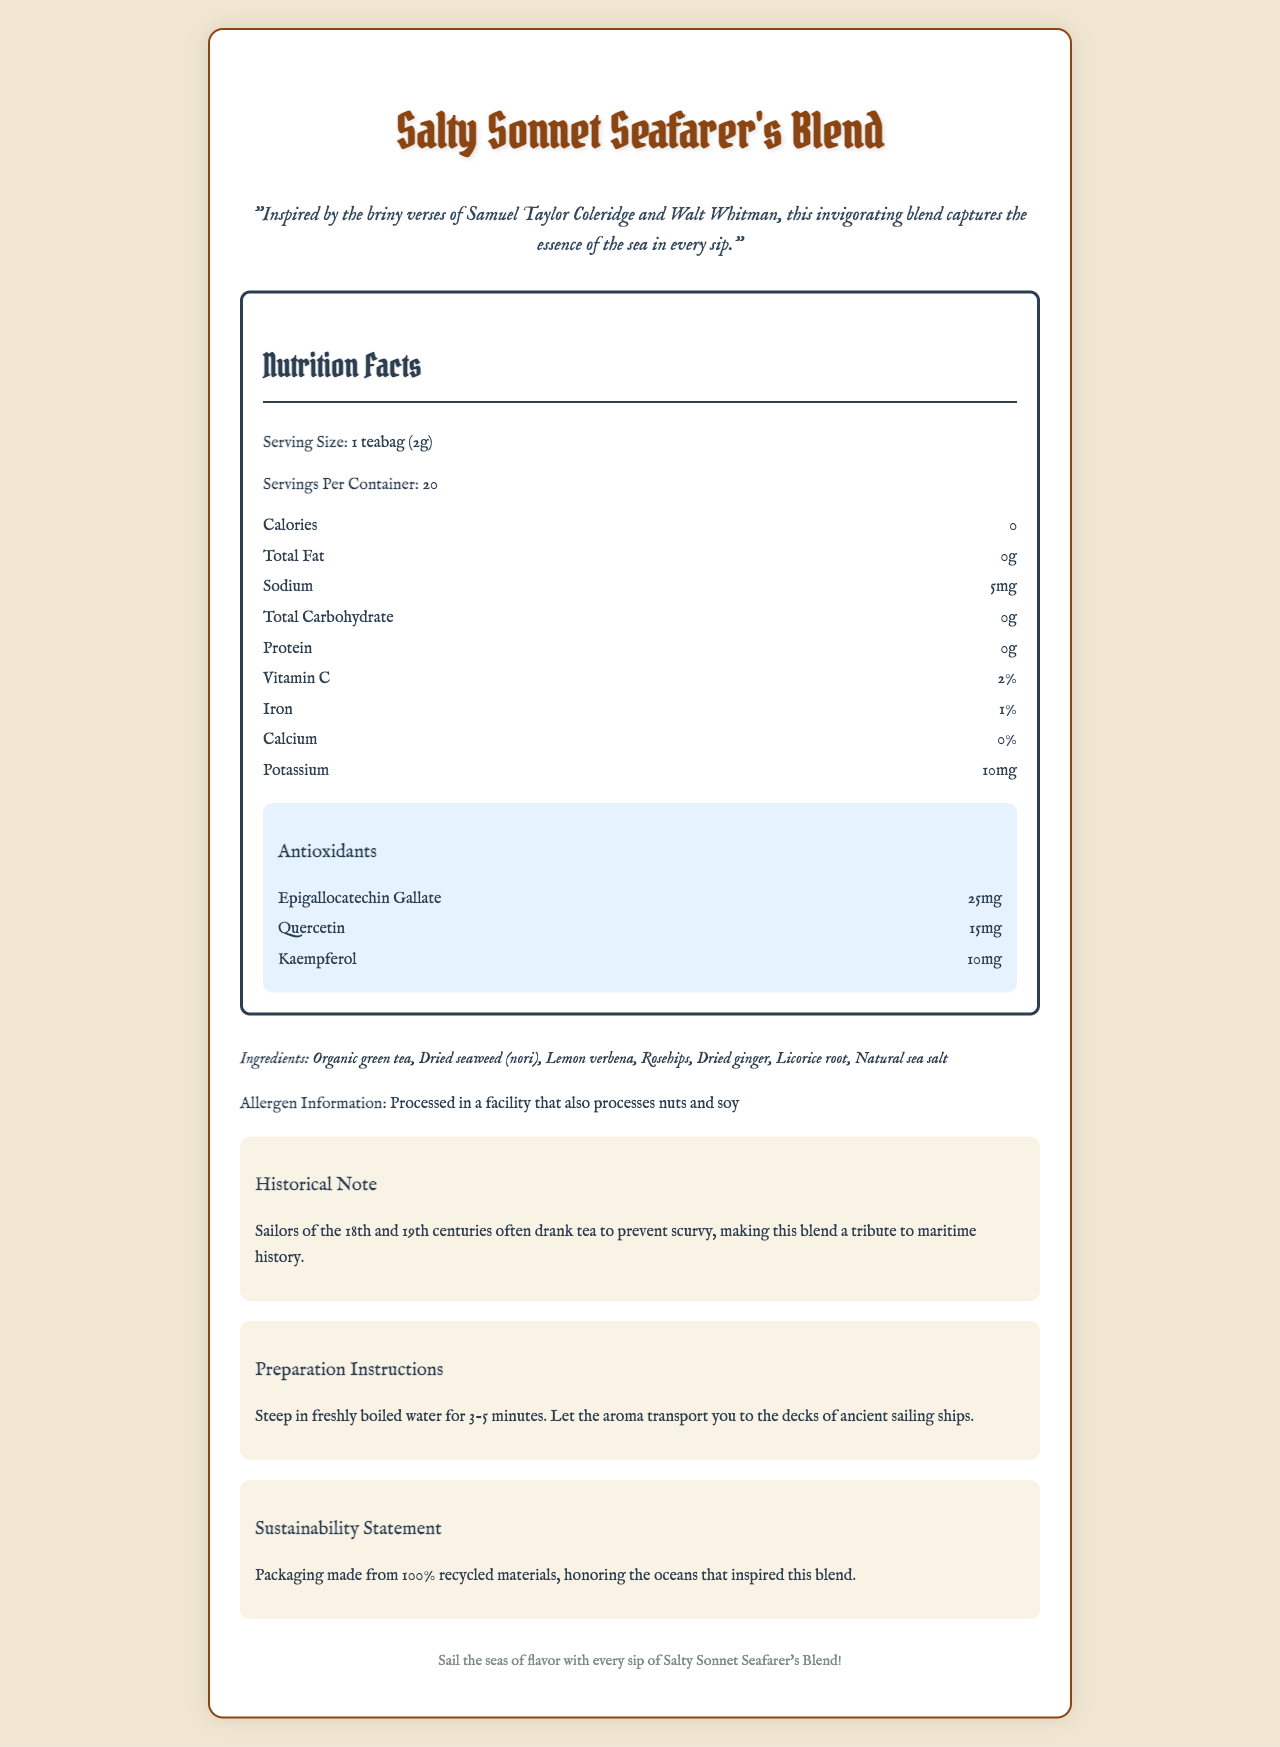what is the serving size for Salty Sonnet Seafarer's Blend? The serving size is directly mentioned in the Nutrition Facts section.
Answer: 1 teabag (2g) how many servings are there per container? The document states that there are 20 servings per container.
Answer: 20 how much sodium does one serving contain? The sodium content per serving is listed under the Nutrition Facts as 5mg.
Answer: 5mg what ingredients are used in the Salty Sonnet Seafarer's Blend? The ingredients are listed in the Ingredients section.
Answer: Organic green tea, Dried seaweed (nori), Lemon verbena, Rosehips, Dried ginger, Licorice root, Natural sea salt what is the poetic inspiration behind Salty Sonnet Seafarer's Blend? The poetic description section mentions that the blend is inspired by Samuel Taylor Coleridge and Walt Whitman.
Answer: The briny verses of Samuel Taylor Coleridge and Walt Whitman which historical practice does this tea blend pay homage to? A. Drinking water on ships B. Sailors drinking coffee C. Sailors drinking tea to prevent scurvy The historical note states that sailors of the 18th and 19th centuries drank tea to prevent scurvy.
Answer: C which antioxidant has the highest content in this tea blend? A. Epigallocatechin Gallate B. Quercetin C. Kaempferol The document lists Epigallocatechin Gallate with 25mg, which is higher than Quercetin (15mg) and Kaempferol (10mg).
Answer: A is the Salty Sonnet Seafarer's Blend processed in a nut-free facility? The allergen information indicates that it is processed in a facility that also processes nuts and soy.
Answer: No does the tea blend contain any calories? The Nutrition Facts state that the calorie content is 0.
Answer: No summarize the main components of the Salty Sonnet Seafarer's Blend document. The document aims to present the tea blend as both a healthful product with robust antioxidant content and a nostalgic tribute to seafarers and poets.
Answer: The document provides a detailed overview of the Salty Sonnet Seafarer's Blend, including nutritional information, ingredient list, antioxidant content, and historical and poetic contextual background. It emphasizes the antioxidant content, highlights its nautical and historical inspiration, and includes preparation instructions and sustainability information. where can you buy this tea blend? The document does not provide any information on where the tea blend can be purchased.
Answer: I don't know 